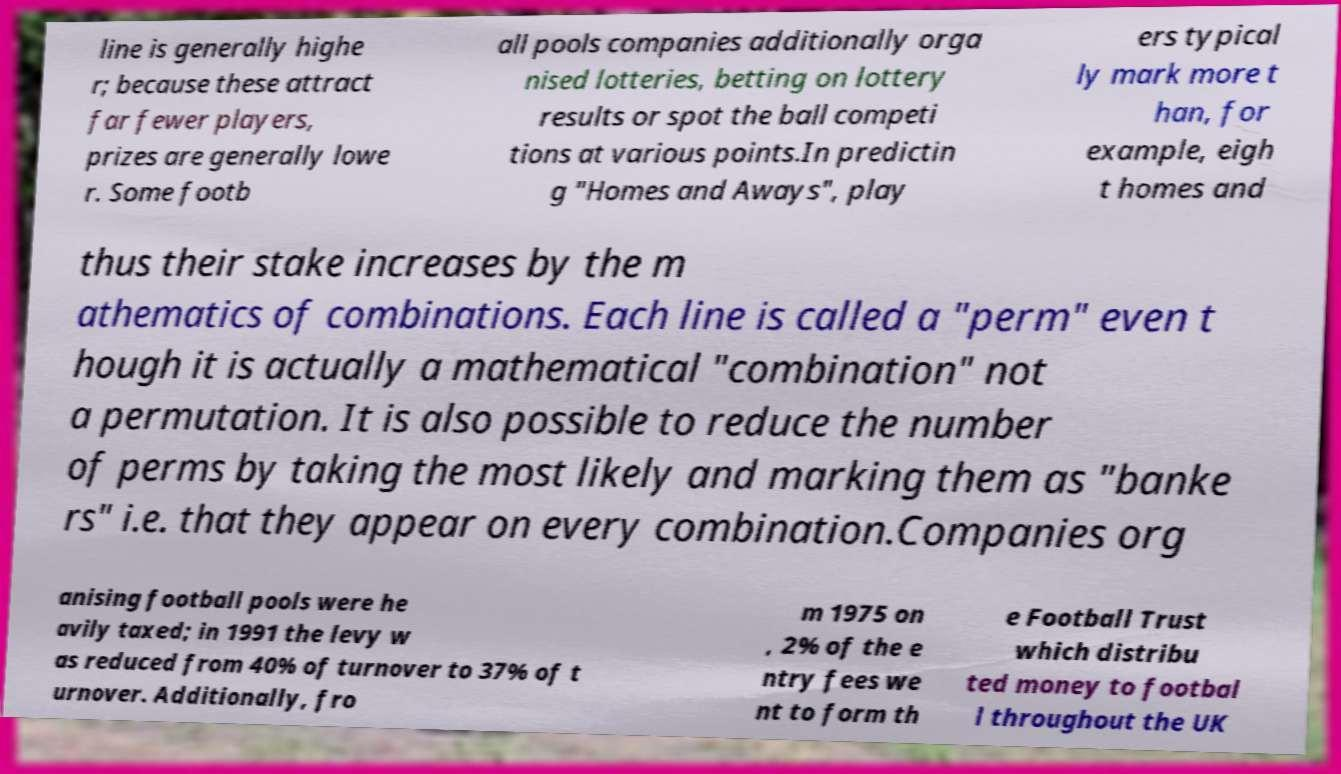I need the written content from this picture converted into text. Can you do that? line is generally highe r; because these attract far fewer players, prizes are generally lowe r. Some footb all pools companies additionally orga nised lotteries, betting on lottery results or spot the ball competi tions at various points.In predictin g "Homes and Aways", play ers typical ly mark more t han, for example, eigh t homes and thus their stake increases by the m athematics of combinations. Each line is called a "perm" even t hough it is actually a mathematical "combination" not a permutation. It is also possible to reduce the number of perms by taking the most likely and marking them as "banke rs" i.e. that they appear on every combination.Companies org anising football pools were he avily taxed; in 1991 the levy w as reduced from 40% of turnover to 37% of t urnover. Additionally, fro m 1975 on , 2% of the e ntry fees we nt to form th e Football Trust which distribu ted money to footbal l throughout the UK 